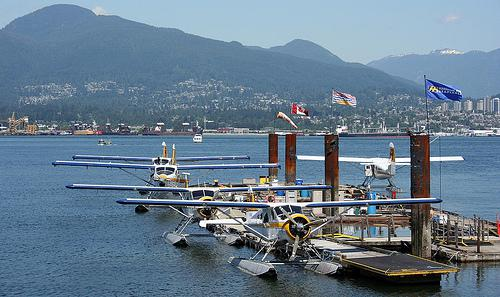Question: what is in the background?
Choices:
A. Mountains.
B. Clouds.
C. The ocean.
D. The forest.
Answer with the letter. Answer: A Question: where is this photo taken?
Choices:
A. On a lake.
B. On a beach.
C. On the dock.
D. In a forest.
Answer with the letter. Answer: A Question: what are parked at the docks?
Choices:
A. Airplanes.
B. The boats.
C. The jet skis.
D. The yacht.
Answer with the letter. Answer: A Question: what color is the sky?
Choices:
A. Blue.
B. White.
C. Pink.
D. Lilac.
Answer with the letter. Answer: A Question: why are the flags flapping?
Choices:
A. They are made of cloth.
B. They are flimsy.
C. Because it is windy.
D. They are in the air.
Answer with the letter. Answer: C 